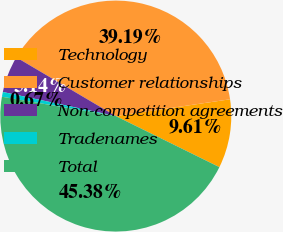Convert chart to OTSL. <chart><loc_0><loc_0><loc_500><loc_500><pie_chart><fcel>Technology<fcel>Customer relationships<fcel>Non-competition agreements<fcel>Tradenames<fcel>Total<nl><fcel>9.61%<fcel>39.19%<fcel>5.14%<fcel>0.67%<fcel>45.38%<nl></chart> 